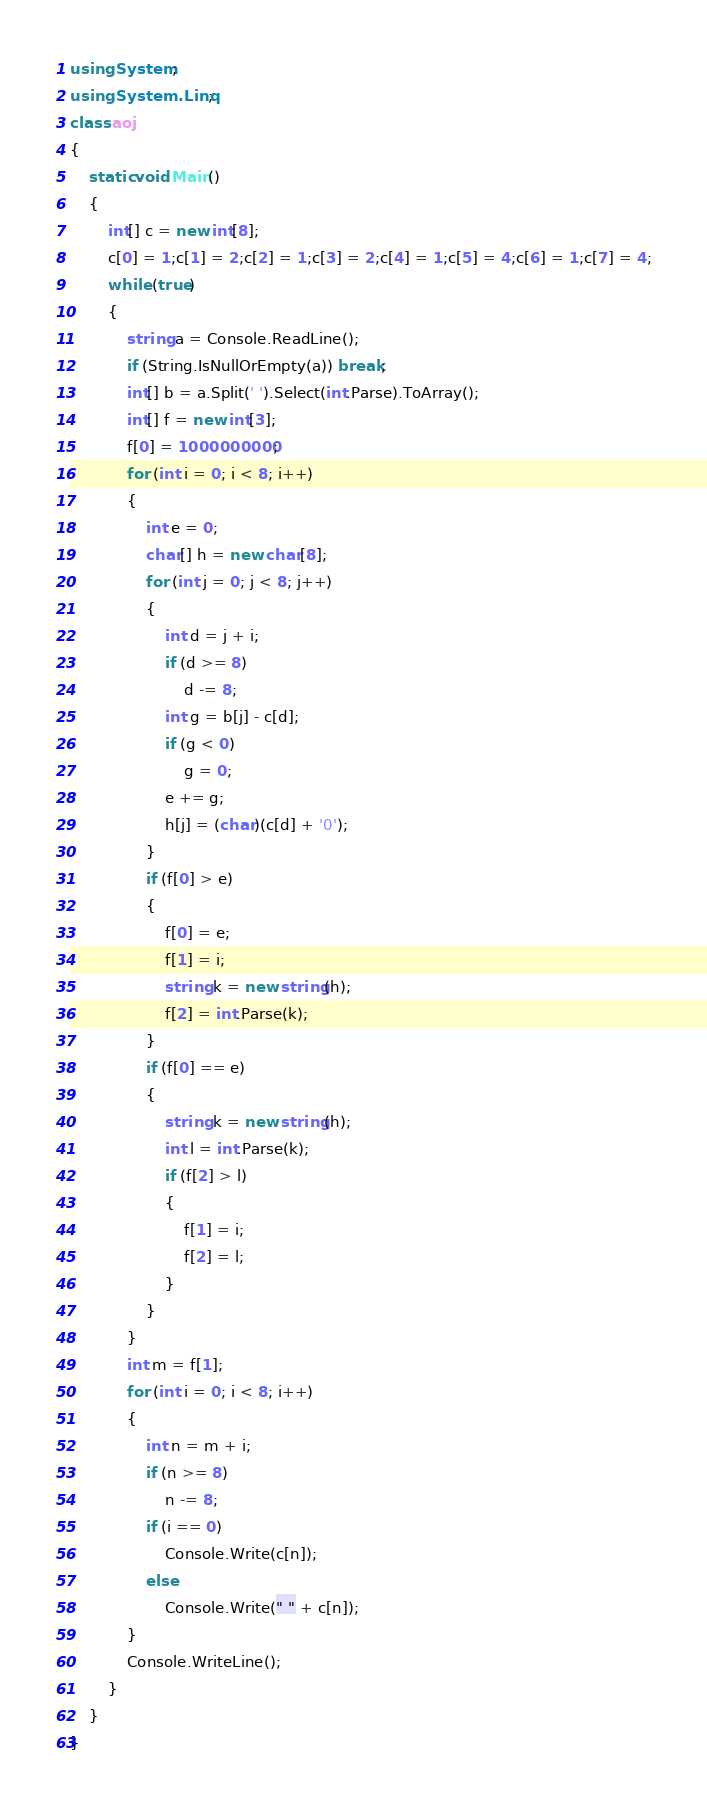Convert code to text. <code><loc_0><loc_0><loc_500><loc_500><_C#_>using System;
using System.Linq;
class aoj
{
    static void Main()
    {
        int[] c = new int[8];
        c[0] = 1;c[1] = 2;c[2] = 1;c[3] = 2;c[4] = 1;c[5] = 4;c[6] = 1;c[7] = 4;
        while (true)
        {
            string a = Console.ReadLine();
            if (String.IsNullOrEmpty(a)) break;
            int[] b = a.Split(' ').Select(int.Parse).ToArray();
            int[] f = new int[3];
            f[0] = 1000000000;
            for (int i = 0; i < 8; i++)
            {
                int e = 0;
                char[] h = new char[8];
                for (int j = 0; j < 8; j++)
                {
                    int d = j + i;
                    if (d >= 8)
                        d -= 8;
                    int g = b[j] - c[d];
                    if (g < 0)
                        g = 0;
                    e += g;
                    h[j] = (char)(c[d] + '0');
                }
                if (f[0] > e)
                {
                    f[0] = e;
                    f[1] = i;
                    string k = new string(h);
                    f[2] = int.Parse(k);
                }
                if (f[0] == e)
                {
                    string k = new string(h);
                    int l = int.Parse(k);
                    if (f[2] > l)
                    {
                        f[1] = i;
                        f[2] = l;
                    }
                }
            }
            int m = f[1];
            for (int i = 0; i < 8; i++)
            {
                int n = m + i;
                if (n >= 8)
                    n -= 8;
                if (i == 0)
                    Console.Write(c[n]);
                else
                    Console.Write(" " + c[n]);
            }
            Console.WriteLine();
        }
    }
}</code> 